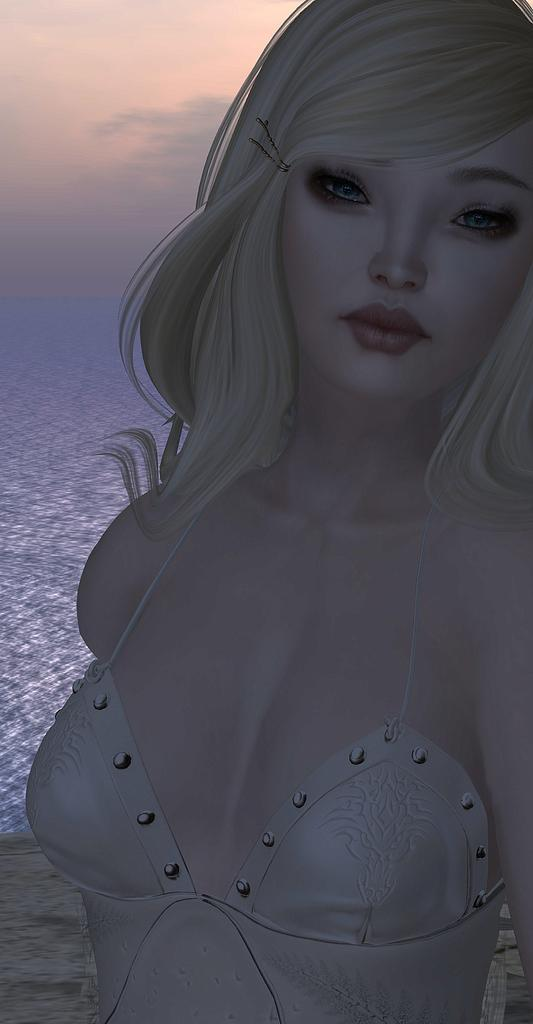What type of image is being described? The image is animated. Can you describe the main character in the image? There is a woman in the front of the image. What natural element is visible in the image? There is water visible in the image. What is visible at the top of the image? The sky is visible at the top of the image. What invention is being compared to the woman in the image? There is no invention being compared to the woman in the image. The image only features a woman and the surrounding environment. 